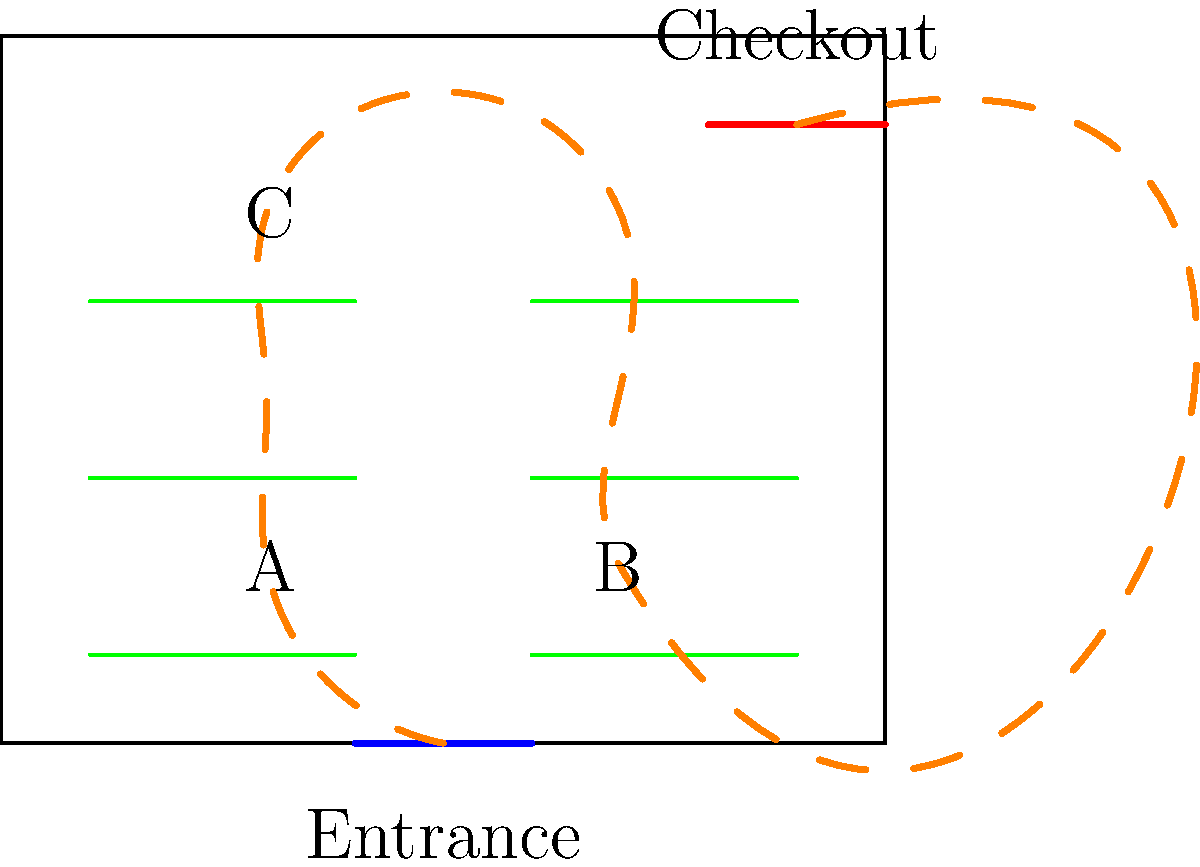Based on the floor plan diagram, which rearrangement of shelves would likely improve customer flow and potentially increase sales in the aftermath of a natural disaster?

A) Swap shelf groups A and B
B) Move shelf group C closer to the entrance
C) Rotate all shelves 90 degrees
D) No changes needed; the current layout is optimal To answer this question, we need to analyze the current store layout and customer flow pattern shown in the diagram. Let's break it down step-by-step:

1. Customer flow: The orange dashed line shows the typical customer path, which follows a serpentine pattern through the store.

2. Current layout analysis:
   - Customers enter through the blue entrance at the bottom.
   - They navigate through shelf groups A, B, and C before reaching the red checkout area.
   - The flow is relatively smooth but requires customers to backtrack slightly.

3. Evaluating options:
   A) Swapping shelf groups A and B:
      - This would create a more direct path from entrance to checkout.
      - It would reduce backtracking and potentially speed up customer flow.
      - In a post-disaster scenario, efficient movement is crucial for serving more customers quickly.

   B) Moving shelf group C closer to the entrance:
      - This would disrupt the natural flow and create congestion near the entrance.
      - It might make it harder for customers to access essential items quickly.

   C) Rotating all shelves 90 degrees:
      - This would create narrow aisles and impede customer movement.
      - It would likely slow down the flow and make it difficult to navigate with carts.

   D) No changes:
      - While the current layout is functional, there's room for improvement in efficiency.

4. Conclusion:
   Option A (swapping shelf groups A and B) is the best choice. It would create a more streamlined path from entrance to checkout, reducing congestion and improving efficiency. This is particularly important in a post-disaster scenario where the store owner needs to serve the community effectively and rebuild the local business.
Answer: Swap shelf groups A and B 